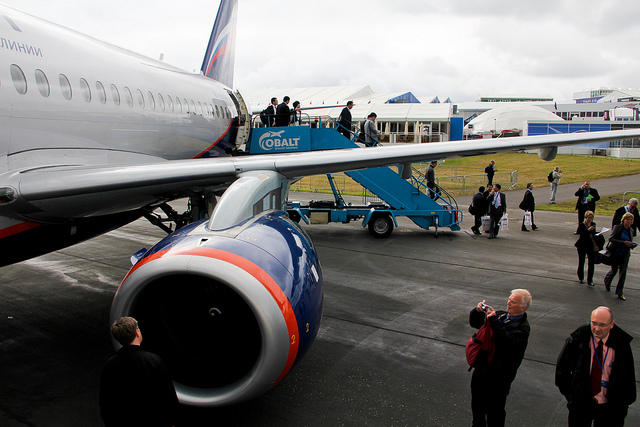Please transcribe the text in this image. OBALT 